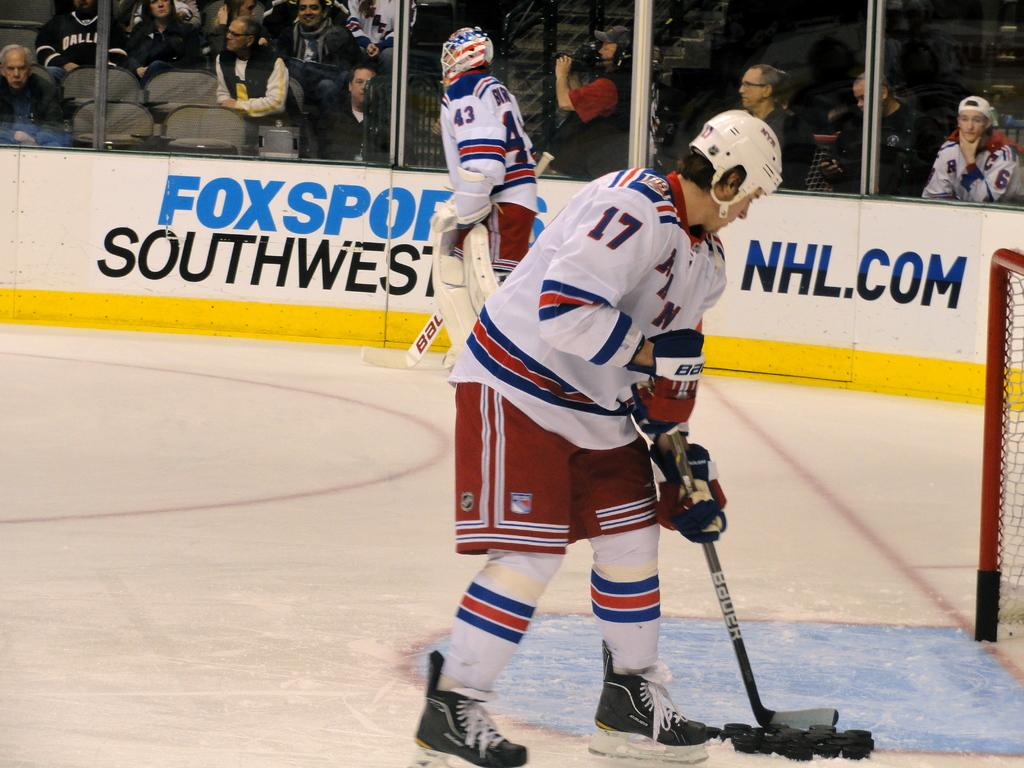<image>
Provide a brief description of the given image. The hockey player number 17 grab some hockey pucks for training. 